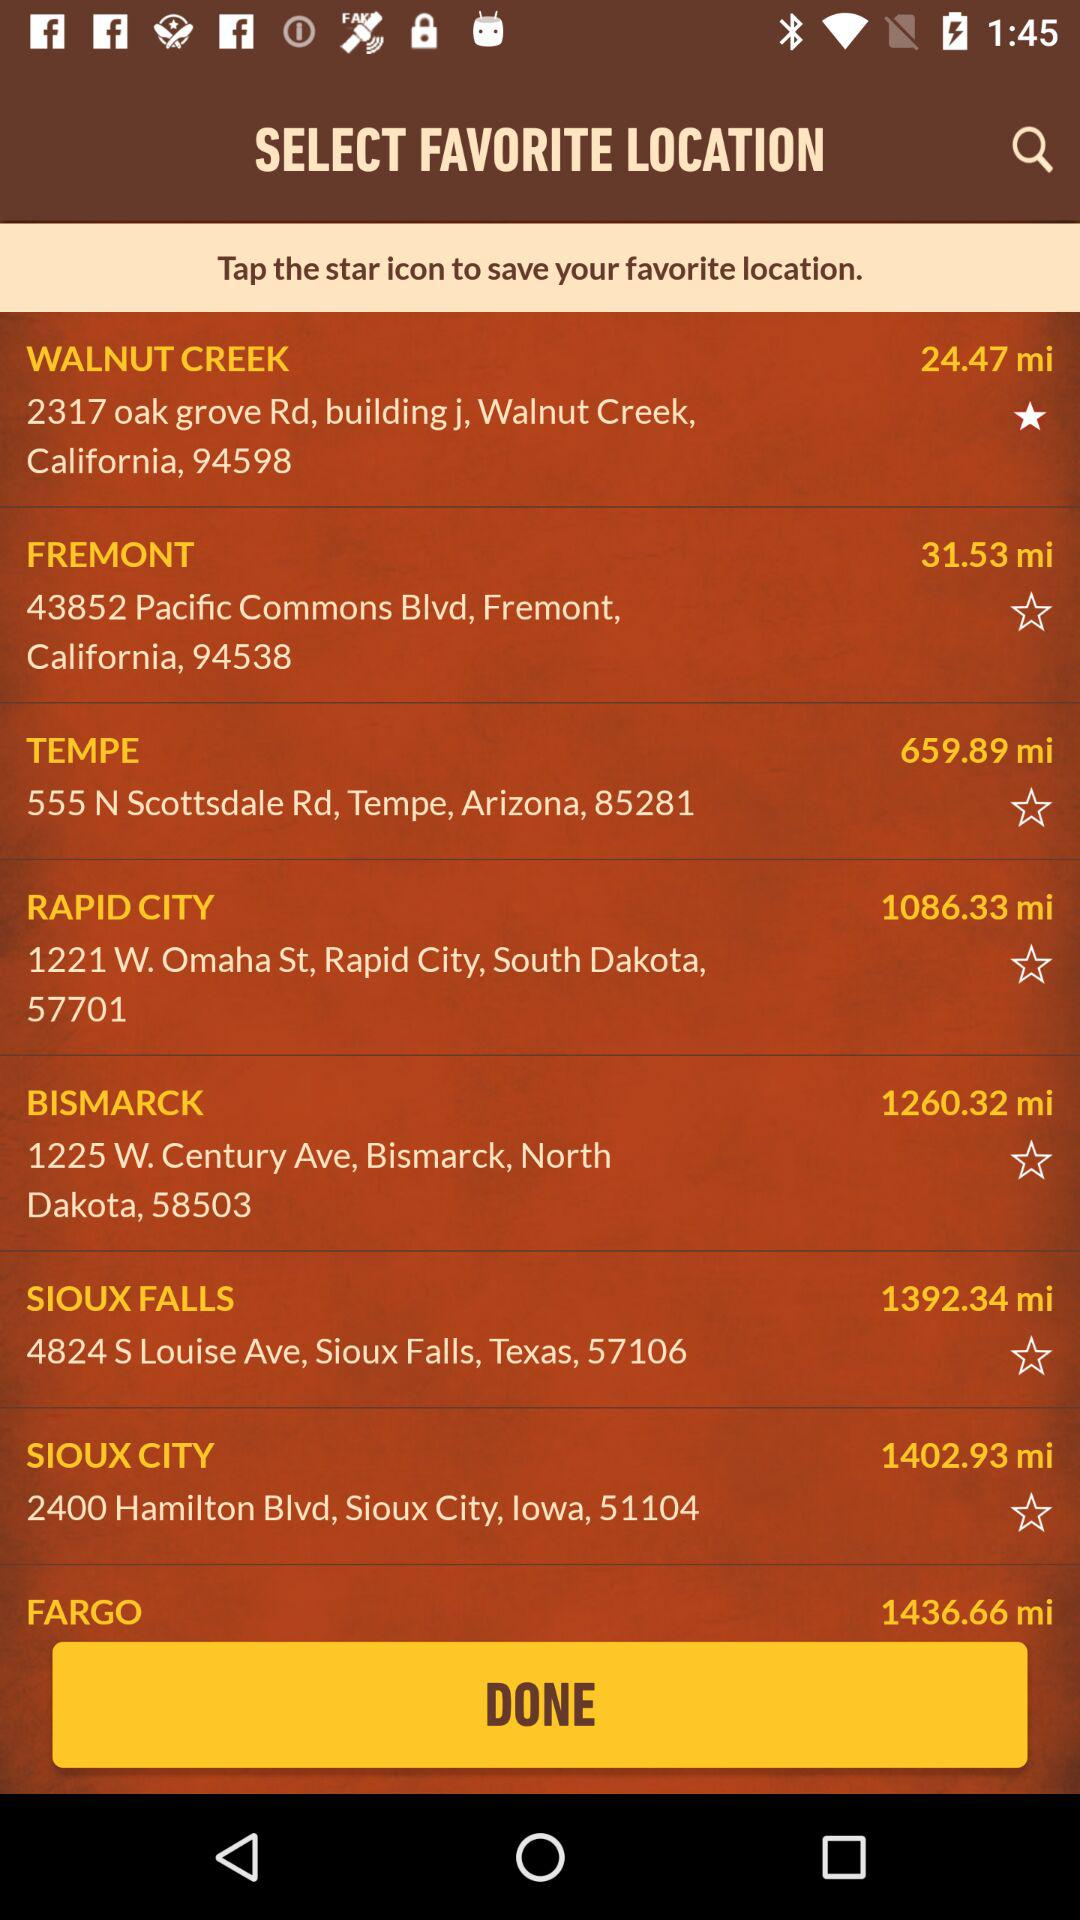How many miles away is Walnut Creek? Walnut Creek is 24.47 miles away. 